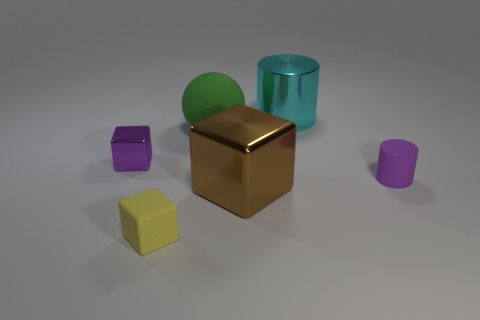Add 2 yellow cubes. How many objects exist? 8 Subtract all balls. How many objects are left? 5 Subtract 0 red cubes. How many objects are left? 6 Subtract all brown shiny cylinders. Subtract all yellow cubes. How many objects are left? 5 Add 1 small matte things. How many small matte things are left? 3 Add 1 cyan metal cylinders. How many cyan metal cylinders exist? 2 